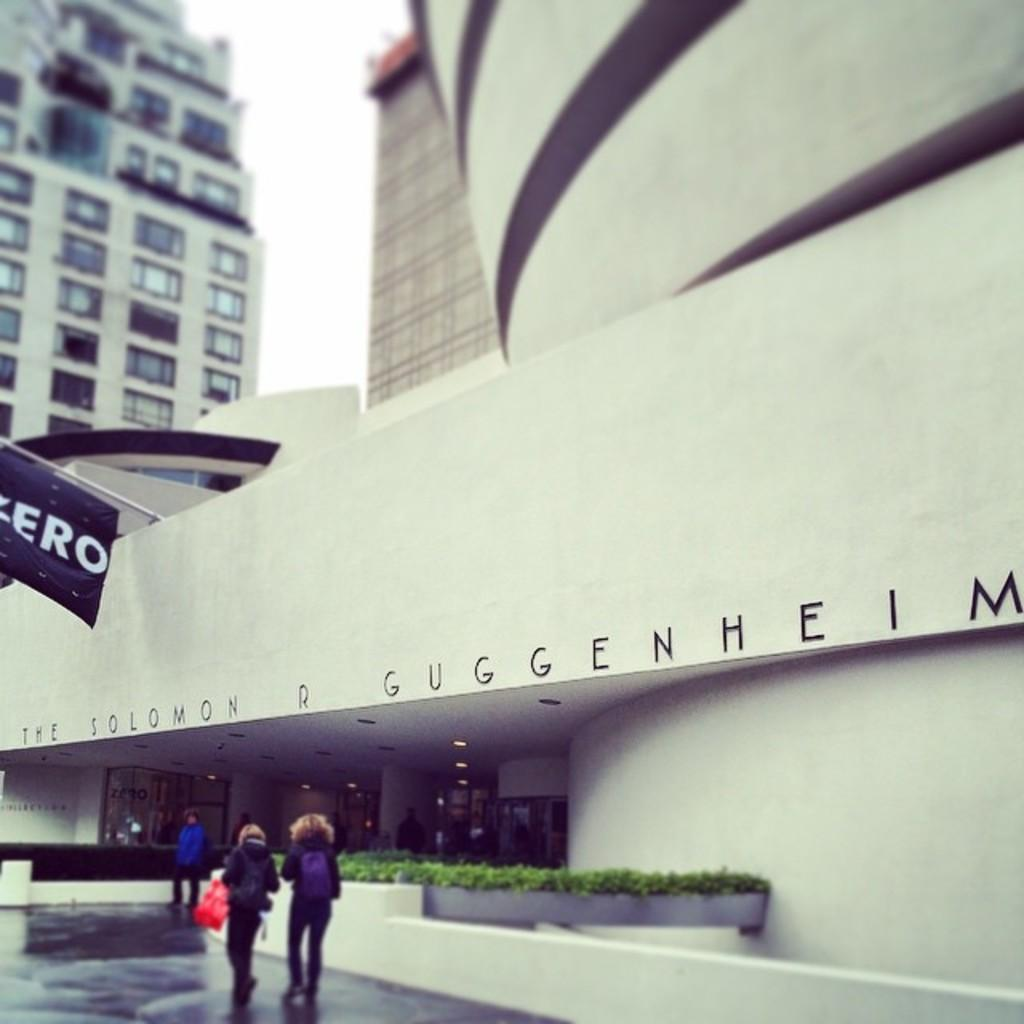What type of structures can be seen in the image? There are buildings in the image. What is hanging or displayed in the image? There is a banner in the image. What architectural features can be observed on the buildings? There are windows visible in the image. What type of vegetation is present in the image? There are plants in the image. What are the people in the image doing? There are people walking in the image. What is visible at the top of the image? The sky is visible at the top of the image. What color is the orange that is being peeled by the person in the image? There is no orange present in the image; it only features buildings, a banner, windows, plants, people walking, and the sky. What word is written on the banner in the image? The provided facts do not mention any specific words on the banner, so we cannot determine what word is written on it. 